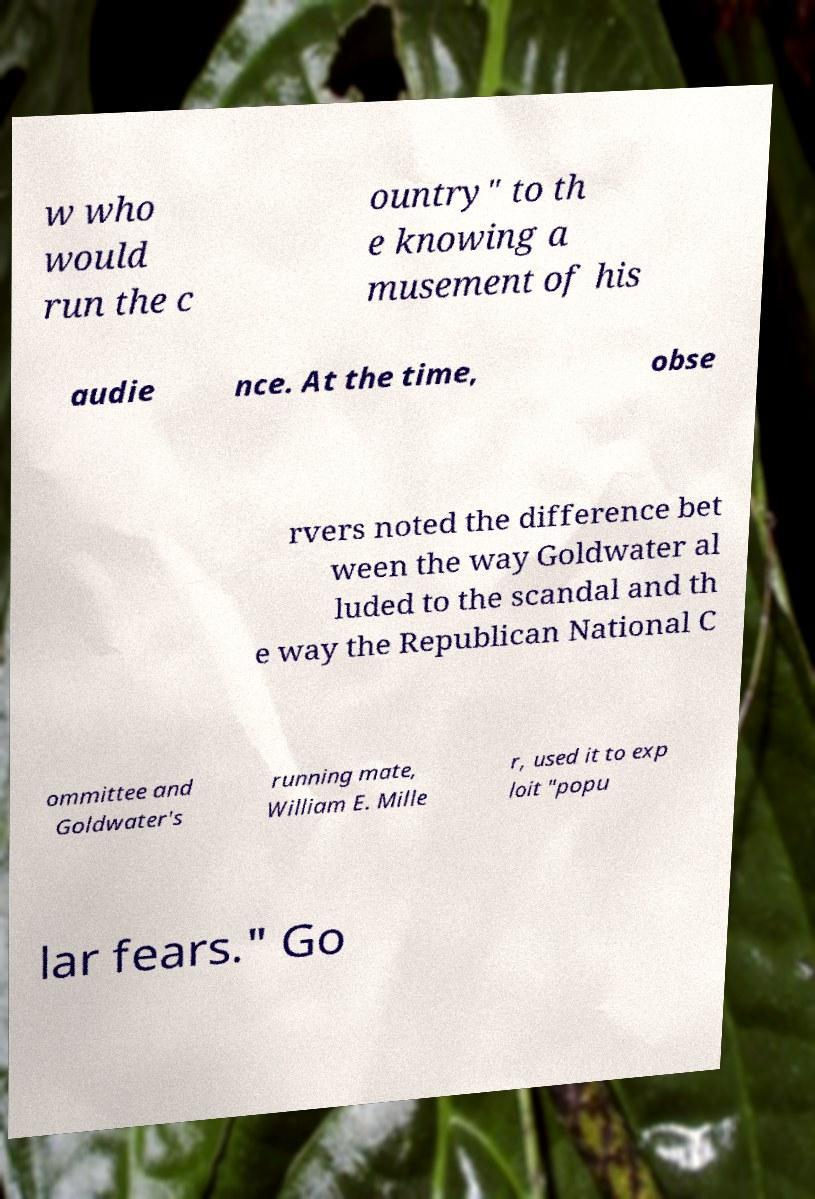What messages or text are displayed in this image? I need them in a readable, typed format. w who would run the c ountry" to th e knowing a musement of his audie nce. At the time, obse rvers noted the difference bet ween the way Goldwater al luded to the scandal and th e way the Republican National C ommittee and Goldwater's running mate, William E. Mille r, used it to exp loit "popu lar fears." Go 